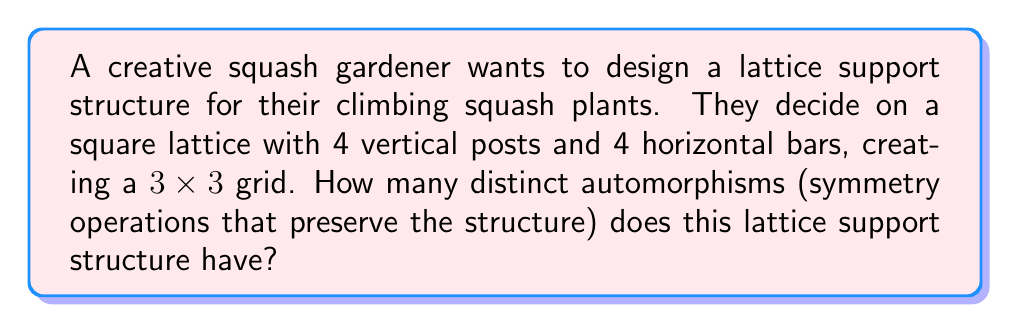Could you help me with this problem? To solve this problem, we need to analyze the symmetries of the square lattice structure:

1. First, let's consider the rotational symmetries:
   - 0° rotation (identity)
   - 90° clockwise rotation
   - 180° rotation
   - 270° clockwise rotation (or 90° counterclockwise)

2. Next, we have reflectional symmetries:
   - Vertical reflection through the center
   - Horizontal reflection through the center
   - Diagonal reflection (top-left to bottom-right)
   - Diagonal reflection (top-right to bottom-left)

Each of these symmetry operations preserves the structure of the lattice, mapping vertices to vertices and edges to edges.

The group of these symmetries is known as the dihedral group $D_4$, which has order 8.

To verify this, we can list all the symmetries:
1. Identity
2. 90° rotation
3. 180° rotation
4. 270° rotation
5. Vertical reflection
6. Horizontal reflection
7. Diagonal reflection (top-left to bottom-right)
8. Diagonal reflection (top-right to bottom-left)

Each of these symmetries is an automorphism of the lattice structure, as it preserves the adjacency relationships between the vertices.

The automorphism group of this lattice is isomorphic to $D_4$, and its order is 8.
Answer: The lattice support structure has 8 distinct automorphisms. 